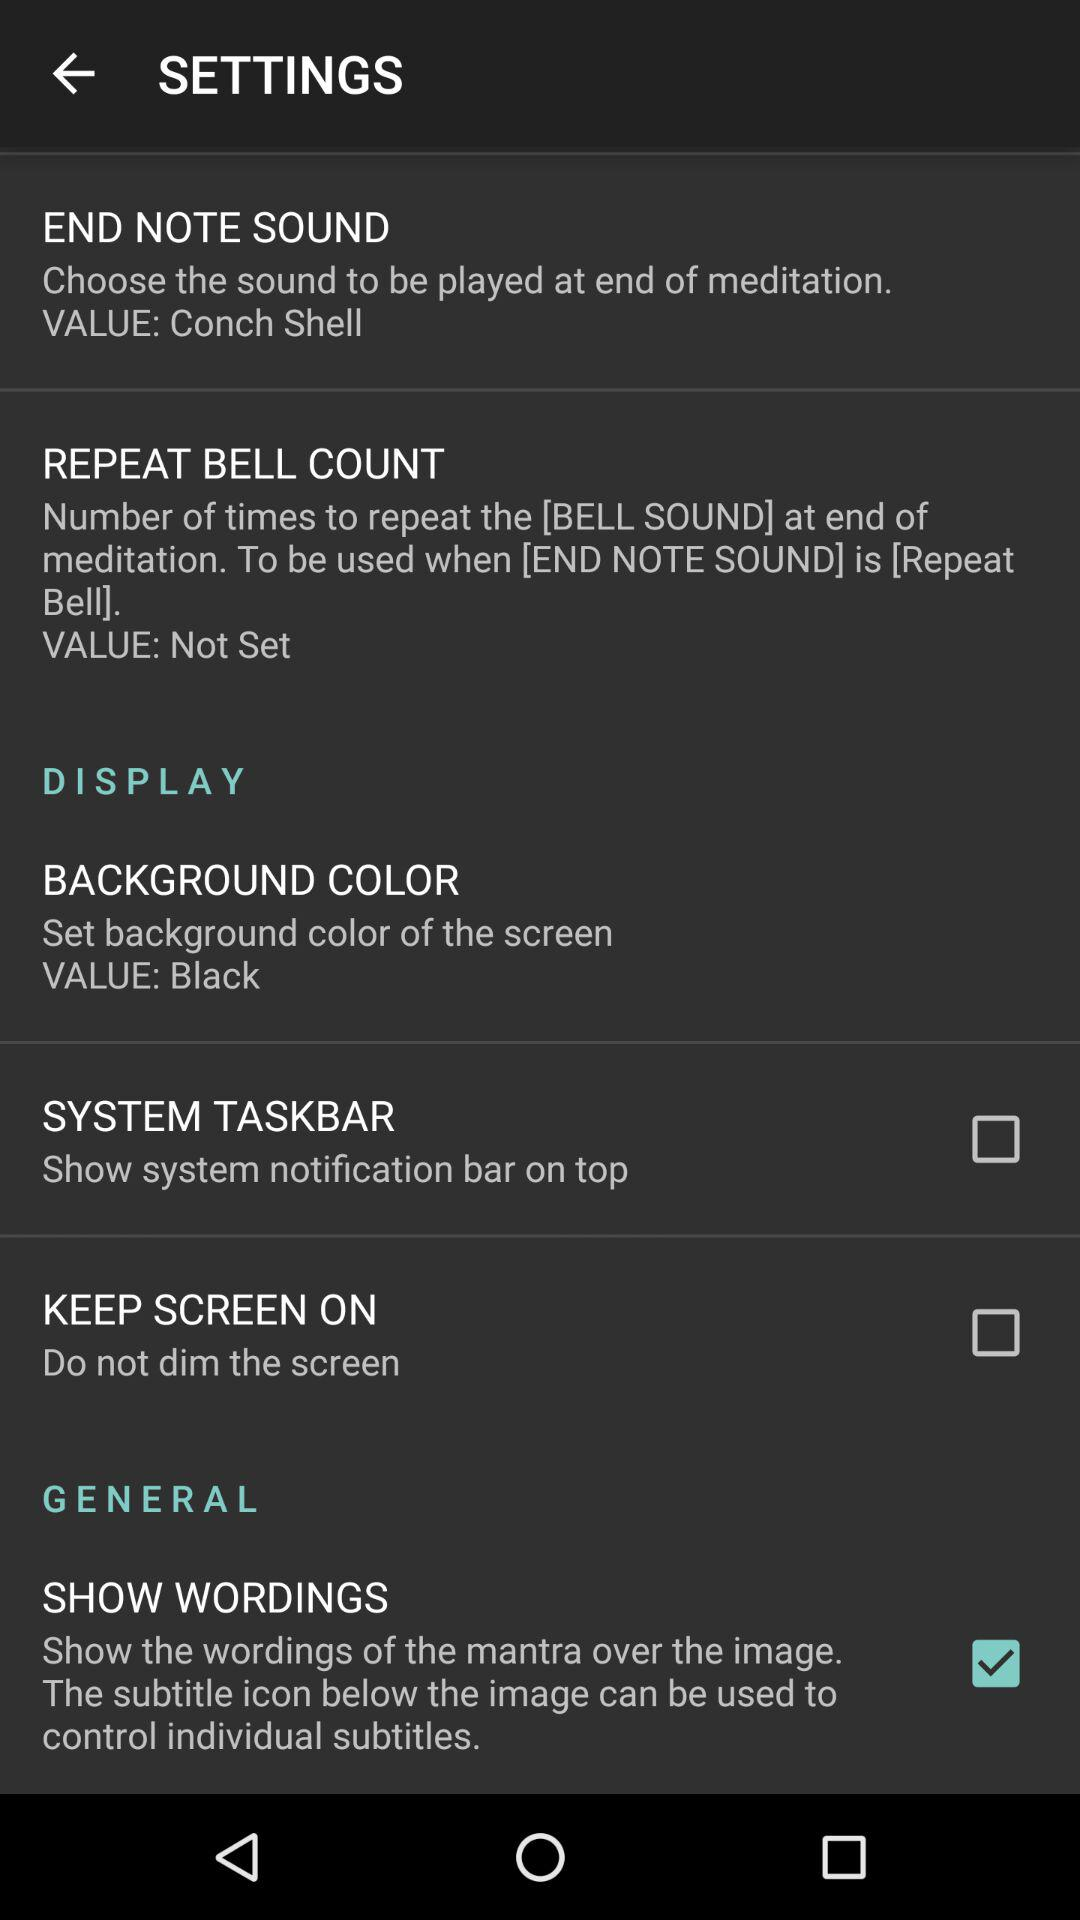What is the set background color? The set background color is black. 